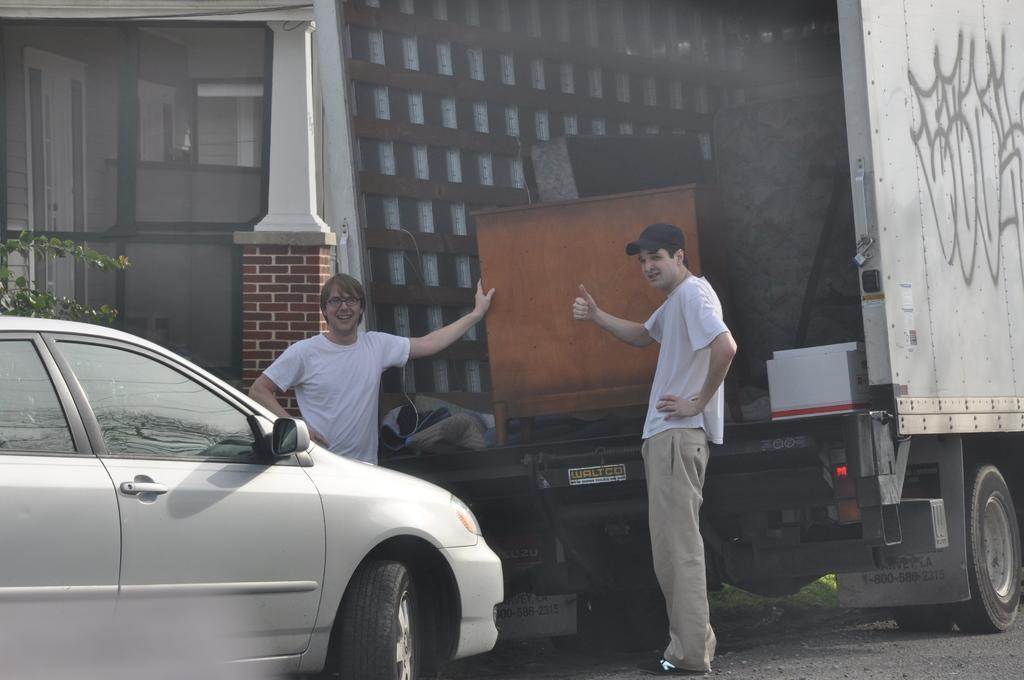Please provide a concise description of this image. In this picture I can observe two men standing behind the truck. In front of them there is a car on the road. In the background I can observe a house. 